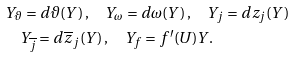<formula> <loc_0><loc_0><loc_500><loc_500>& Y _ { \vartheta } = d \vartheta ( Y ) \, , \quad Y _ { \omega } = d \omega ( Y ) \, , \quad Y _ { j } = d z _ { j } ( Y ) \\ & \quad Y _ { \overline { j } } = d \overline { z } _ { j } ( Y ) \, , \quad Y _ { f } = f ^ { \prime } ( U ) Y .</formula> 